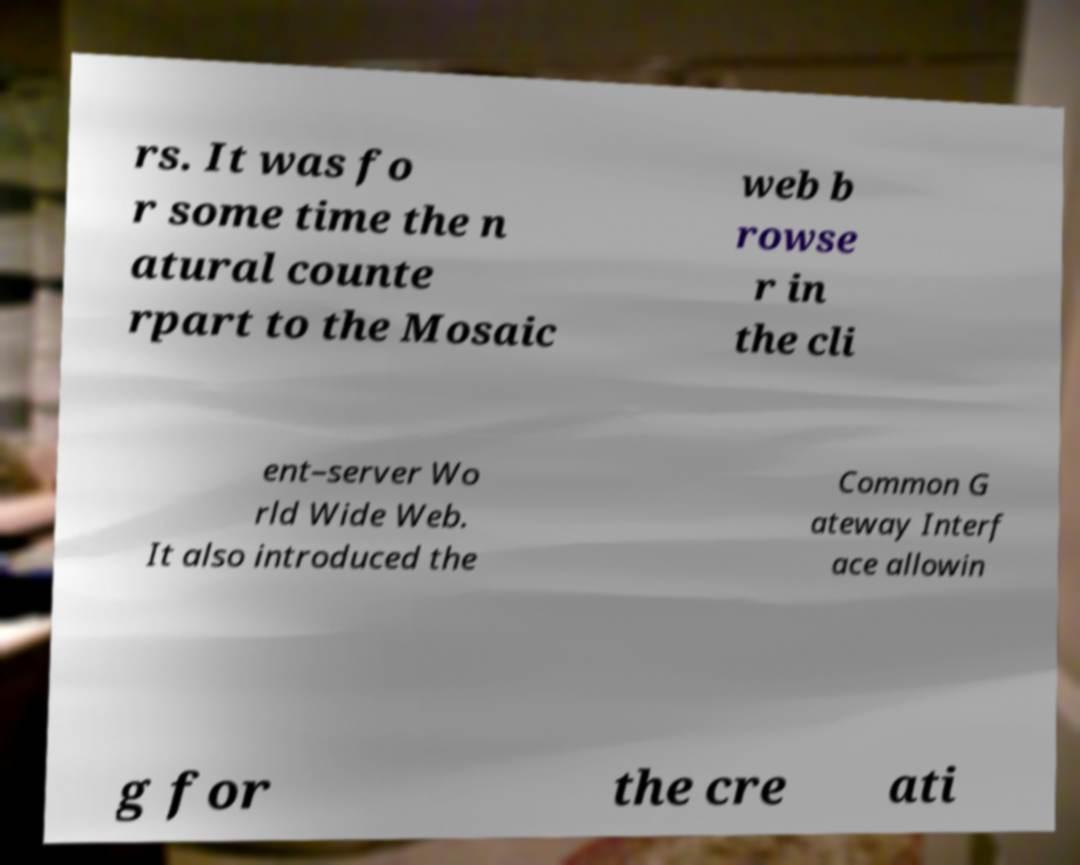Please read and relay the text visible in this image. What does it say? rs. It was fo r some time the n atural counte rpart to the Mosaic web b rowse r in the cli ent–server Wo rld Wide Web. It also introduced the Common G ateway Interf ace allowin g for the cre ati 